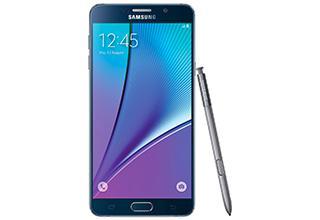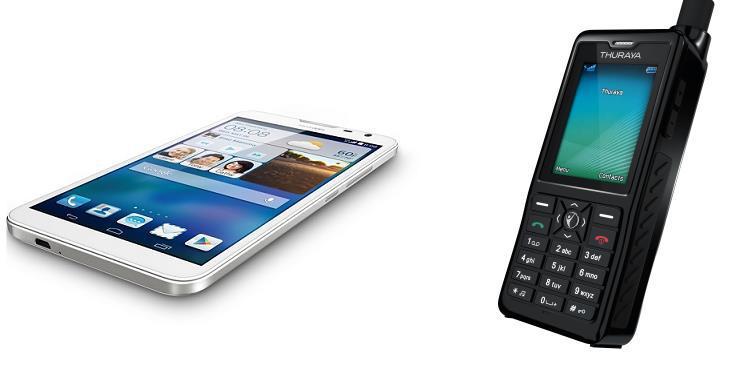The first image is the image on the left, the second image is the image on the right. For the images shown, is this caption "One phone is white around the screen." true? Answer yes or no. Yes. The first image is the image on the left, the second image is the image on the right. Assess this claim about the two images: "One image shows a flat phone with a big screen displayed head-on and vertically, and the other image includes a phone with an antenna that is displayed at an angle.". Correct or not? Answer yes or no. Yes. 